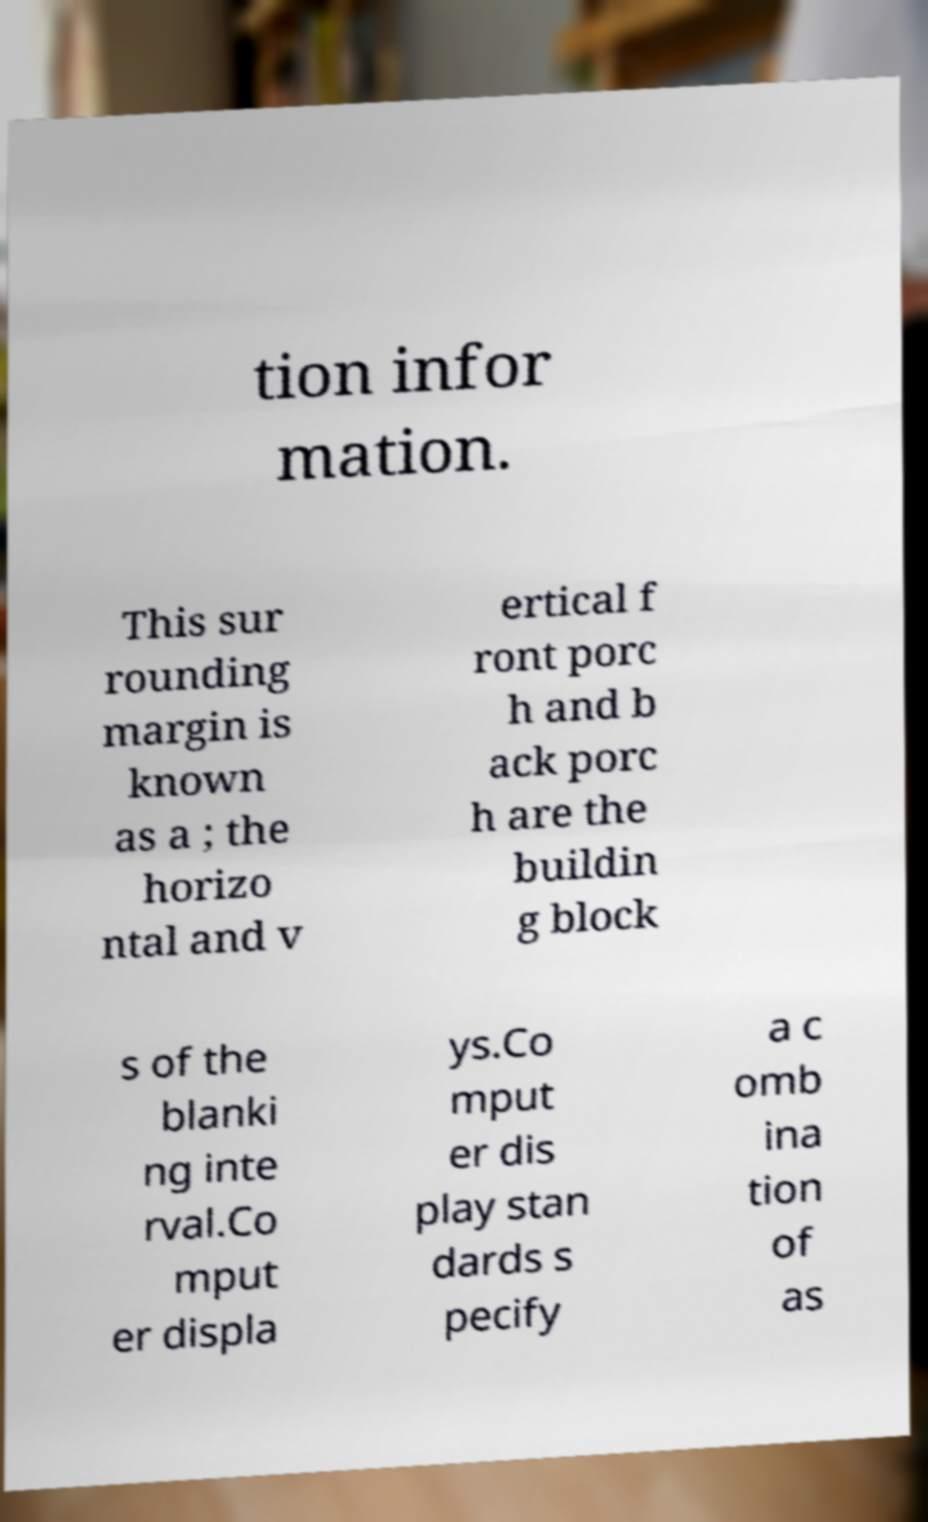Could you assist in decoding the text presented in this image and type it out clearly? tion infor mation. This sur rounding margin is known as a ; the horizo ntal and v ertical f ront porc h and b ack porc h are the buildin g block s of the blanki ng inte rval.Co mput er displa ys.Co mput er dis play stan dards s pecify a c omb ina tion of as 